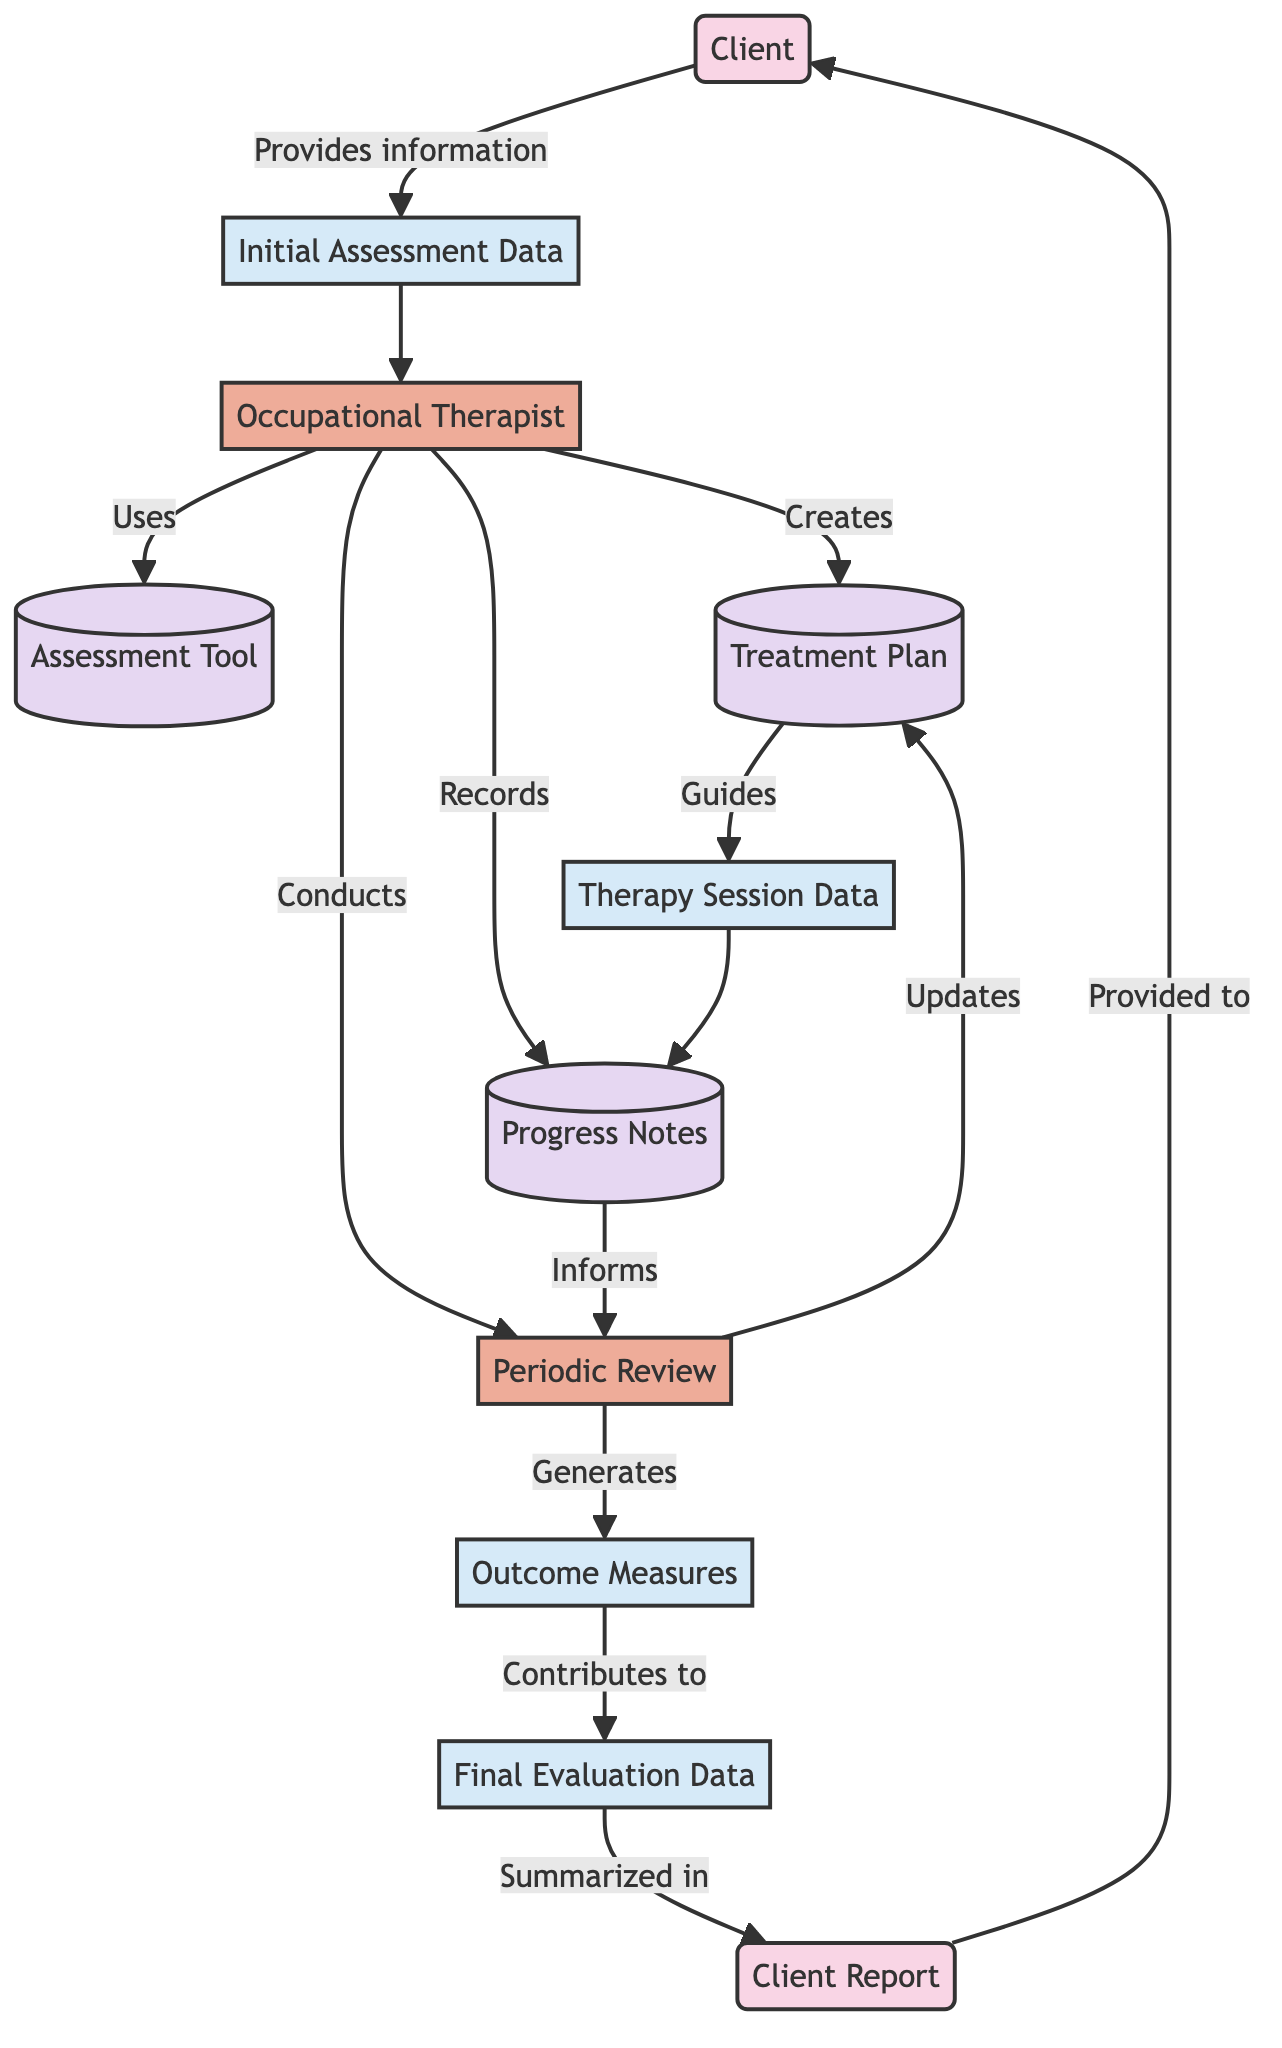What is the client in the diagram? The client is identified as the individual receiving occupational therapy services, represented as an external entity in the diagram.
Answer: Client How many data stores are present in the diagram? Upon reviewing the diagram, there are four identifiable data stores: Assessment Tool, Progress Notes, Treatment Plan, and one more not explicitly demanded. Thus, it counts as four in total.
Answer: Four What does the Occupational Therapist do with the Initial Assessment Data? The Occupational Therapist receives or utilizes the Initial Assessment Data to conduct an evaluation of the client's needs and progress following its reception from the client in the flow.
Answer: Uses Which element generates Outcome Measures? The Outcome Measures are generated as a result of the Periodic Review conducted by the Occupational Therapist based on the information compiled during the therapy sessions and progress notes.
Answer: Periodic Review What is included in the Final Evaluation Data? The Final Evaluation Data includes an overall assessment of the client's improvements and outcomes at the end of the therapy process, compiling all previous measures and evaluations.
Answer: Overall outcomes What is the relationship between Treatment Plan and Therapy Session Data? The Treatment Plan guides the Therapy Session Data, indicating that the planned interventions influence how the sessions and their records are organized.
Answer: Guides Which element is provided to the Client? The Client Report is specifically mentioned as the element provided to the Client, summarizing the client's progress and outcomes throughout therapy sessions.
Answer: Client Report What role does Progress Notes play in the Periodic Review? Progress Notes inform the Periodic Review by documenting ongoing client progress and session details, which are necessary for the review process to adapt the treatment plan accordingly.
Answer: Informs What type of diagram is shown in the document provided? This diagram is a Data Flow Diagram, which illustrates the flow of information and processes related to Tracking Progress and Outcome Measurement in occupational therapy.
Answer: Data Flow Diagram 